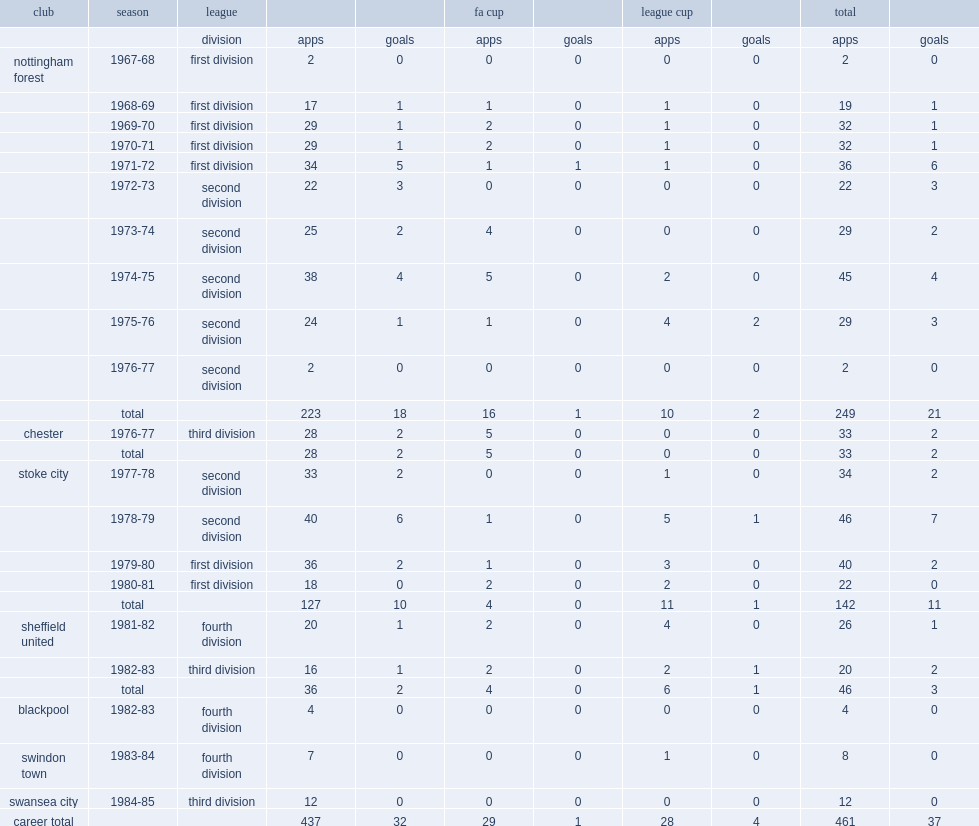How many appearances did richardson make for forest? 249.0. How many goals did richardson score for forest? 21.0. 